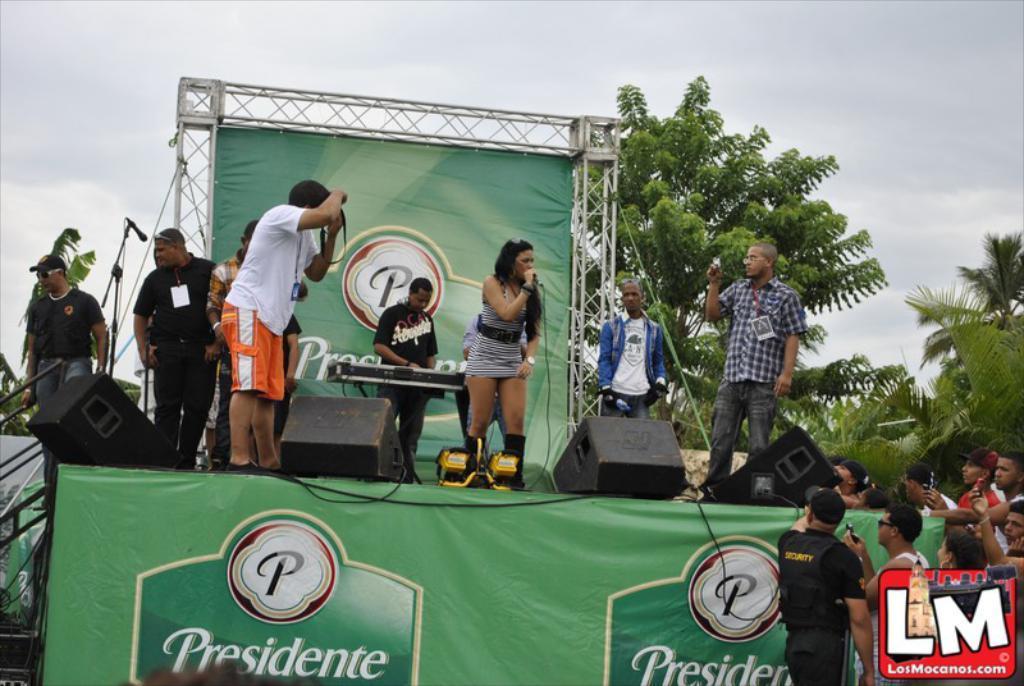Please provide a concise description of this image. In the center of the image we can see a lady standing and holding a mic in her hand. On the left there is a man holding a camera in his hand. On the right there is a man standing. In the background we can see a person playing piano. On the left there are people. On the right there is crowd. We can see speakers. In the background there are trees and sky. 